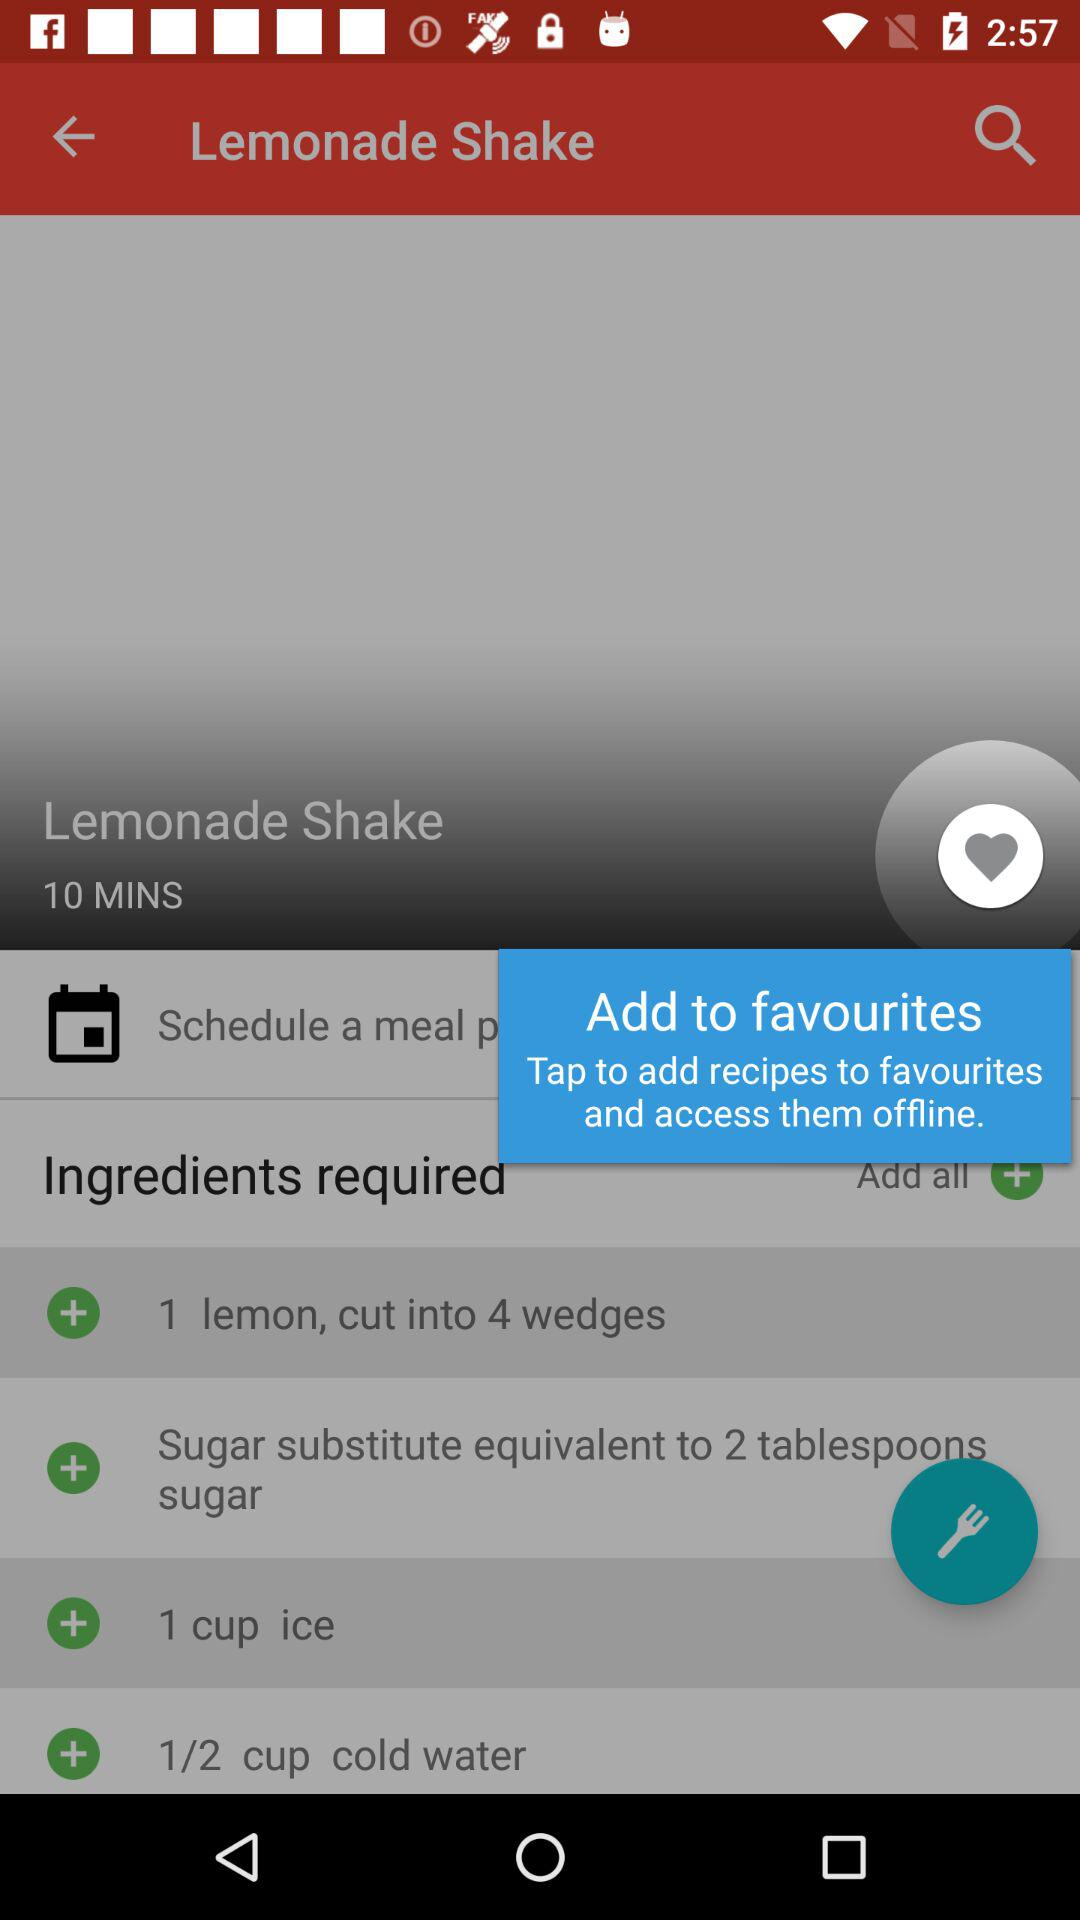How much cold water is needed to prepare a lemonade shake? For preparing lemonade, 1/2 cup of cold water is needed. 